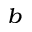Convert formula to latex. <formula><loc_0><loc_0><loc_500><loc_500>^ { b }</formula> 